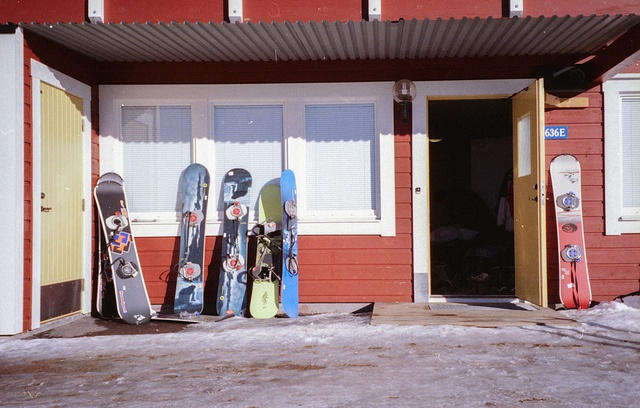Describe the objects in this image and their specific colors. I can see snowboard in maroon, darkgray, gray, lightgray, and black tones, snowboard in maroon, lightgray, lightpink, salmon, and darkgray tones, snowboard in maroon, gray, darkgray, and lavender tones, snowboard in maroon, gray, lightgray, and darkgray tones, and snowboard in maroon, black, beige, olive, and gray tones in this image. 